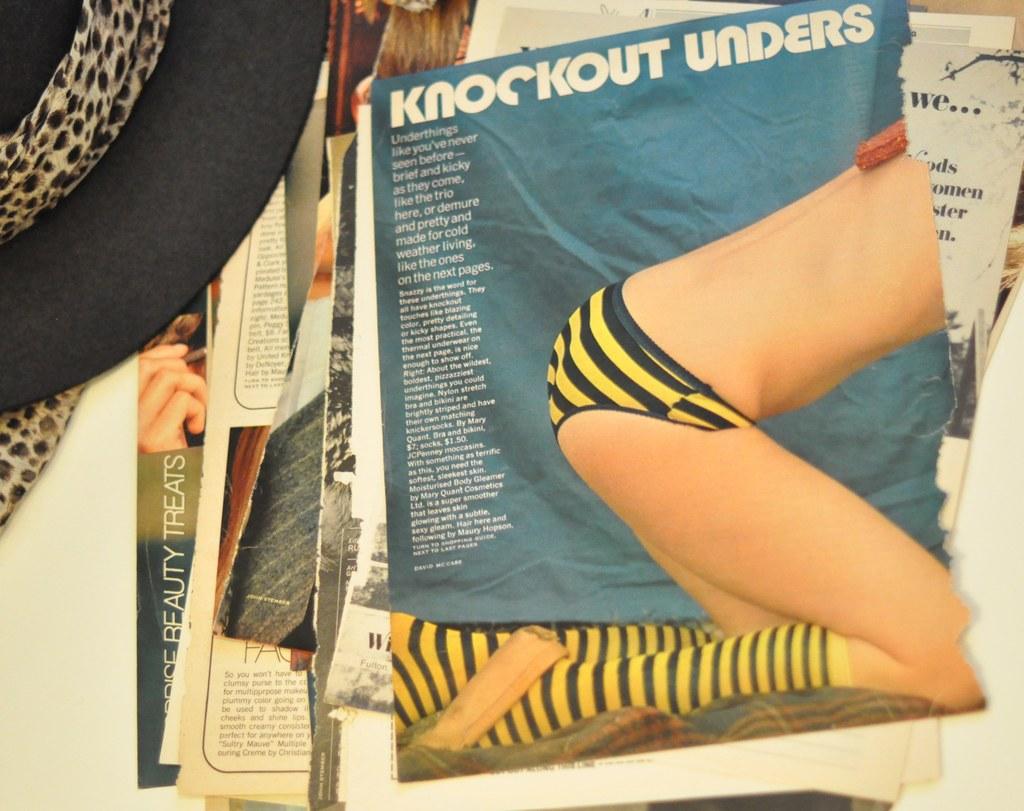What is this advertisement for?
Your answer should be very brief. Knockout unders. What is the magazine title?
Your answer should be compact. Knockout unders. 